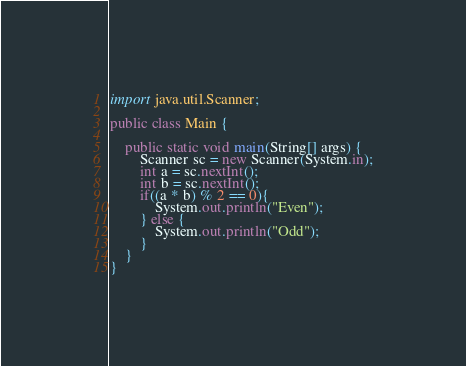<code> <loc_0><loc_0><loc_500><loc_500><_Java_>import java.util.Scanner;

public class Main {

    public static void main(String[] args) {
        Scanner sc = new Scanner(System.in);
        int a = sc.nextInt();
        int b = sc.nextInt();
        if((a * b) % 2 == 0){
            System.out.println("Even");
        } else {
            System.out.println("Odd");
        }
    }
}</code> 